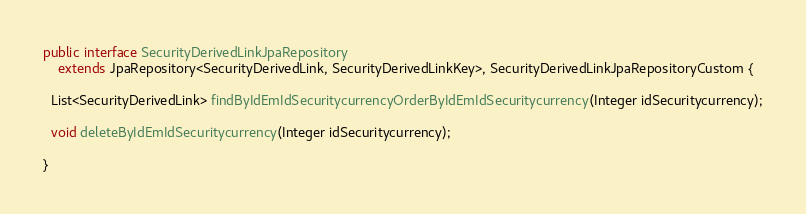Convert code to text. <code><loc_0><loc_0><loc_500><loc_500><_Java_>public interface SecurityDerivedLinkJpaRepository
    extends JpaRepository<SecurityDerivedLink, SecurityDerivedLinkKey>, SecurityDerivedLinkJpaRepositoryCustom {

  List<SecurityDerivedLink> findByIdEmIdSecuritycurrencyOrderByIdEmIdSecuritycurrency(Integer idSecuritycurrency);

  void deleteByIdEmIdSecuritycurrency(Integer idSecuritycurrency);

}
</code> 